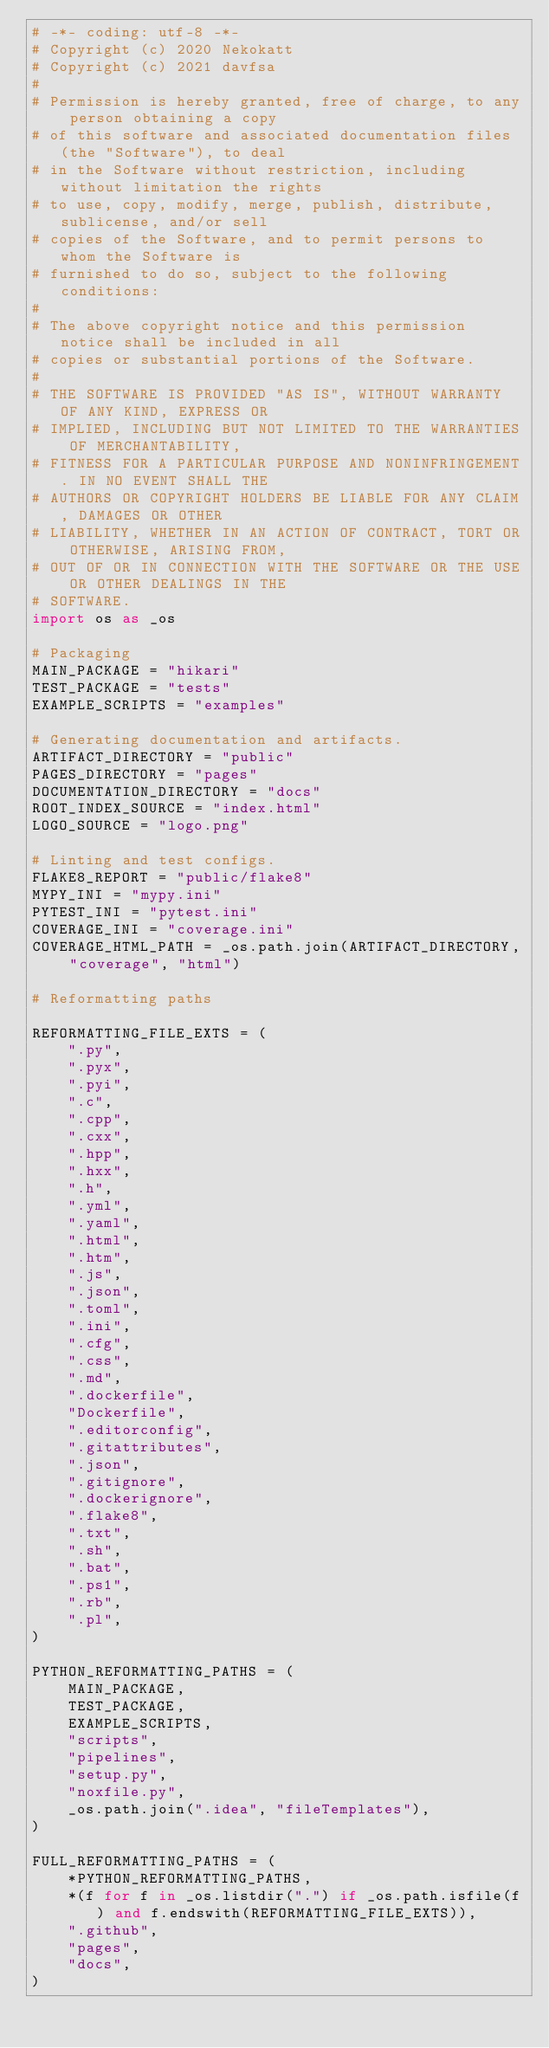Convert code to text. <code><loc_0><loc_0><loc_500><loc_500><_Python_># -*- coding: utf-8 -*-
# Copyright (c) 2020 Nekokatt
# Copyright (c) 2021 davfsa
#
# Permission is hereby granted, free of charge, to any person obtaining a copy
# of this software and associated documentation files (the "Software"), to deal
# in the Software without restriction, including without limitation the rights
# to use, copy, modify, merge, publish, distribute, sublicense, and/or sell
# copies of the Software, and to permit persons to whom the Software is
# furnished to do so, subject to the following conditions:
#
# The above copyright notice and this permission notice shall be included in all
# copies or substantial portions of the Software.
#
# THE SOFTWARE IS PROVIDED "AS IS", WITHOUT WARRANTY OF ANY KIND, EXPRESS OR
# IMPLIED, INCLUDING BUT NOT LIMITED TO THE WARRANTIES OF MERCHANTABILITY,
# FITNESS FOR A PARTICULAR PURPOSE AND NONINFRINGEMENT. IN NO EVENT SHALL THE
# AUTHORS OR COPYRIGHT HOLDERS BE LIABLE FOR ANY CLAIM, DAMAGES OR OTHER
# LIABILITY, WHETHER IN AN ACTION OF CONTRACT, TORT OR OTHERWISE, ARISING FROM,
# OUT OF OR IN CONNECTION WITH THE SOFTWARE OR THE USE OR OTHER DEALINGS IN THE
# SOFTWARE.
import os as _os

# Packaging
MAIN_PACKAGE = "hikari"
TEST_PACKAGE = "tests"
EXAMPLE_SCRIPTS = "examples"

# Generating documentation and artifacts.
ARTIFACT_DIRECTORY = "public"
PAGES_DIRECTORY = "pages"
DOCUMENTATION_DIRECTORY = "docs"
ROOT_INDEX_SOURCE = "index.html"
LOGO_SOURCE = "logo.png"

# Linting and test configs.
FLAKE8_REPORT = "public/flake8"
MYPY_INI = "mypy.ini"
PYTEST_INI = "pytest.ini"
COVERAGE_INI = "coverage.ini"
COVERAGE_HTML_PATH = _os.path.join(ARTIFACT_DIRECTORY, "coverage", "html")

# Reformatting paths

REFORMATTING_FILE_EXTS = (
    ".py",
    ".pyx",
    ".pyi",
    ".c",
    ".cpp",
    ".cxx",
    ".hpp",
    ".hxx",
    ".h",
    ".yml",
    ".yaml",
    ".html",
    ".htm",
    ".js",
    ".json",
    ".toml",
    ".ini",
    ".cfg",
    ".css",
    ".md",
    ".dockerfile",
    "Dockerfile",
    ".editorconfig",
    ".gitattributes",
    ".json",
    ".gitignore",
    ".dockerignore",
    ".flake8",
    ".txt",
    ".sh",
    ".bat",
    ".ps1",
    ".rb",
    ".pl",
)

PYTHON_REFORMATTING_PATHS = (
    MAIN_PACKAGE,
    TEST_PACKAGE,
    EXAMPLE_SCRIPTS,
    "scripts",
    "pipelines",
    "setup.py",
    "noxfile.py",
    _os.path.join(".idea", "fileTemplates"),
)

FULL_REFORMATTING_PATHS = (
    *PYTHON_REFORMATTING_PATHS,
    *(f for f in _os.listdir(".") if _os.path.isfile(f) and f.endswith(REFORMATTING_FILE_EXTS)),
    ".github",
    "pages",
    "docs",
)
</code> 